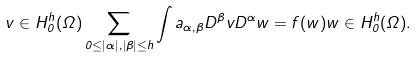<formula> <loc_0><loc_0><loc_500><loc_500>v \in H ^ { h } _ { 0 } ( \Omega ) \sum _ { 0 \leq | \alpha | , | \beta | \leq h } \int a _ { \alpha , \beta } D ^ { \beta } v D ^ { \alpha } w = f ( w ) w \in H ^ { h } _ { 0 } ( \Omega ) .</formula> 